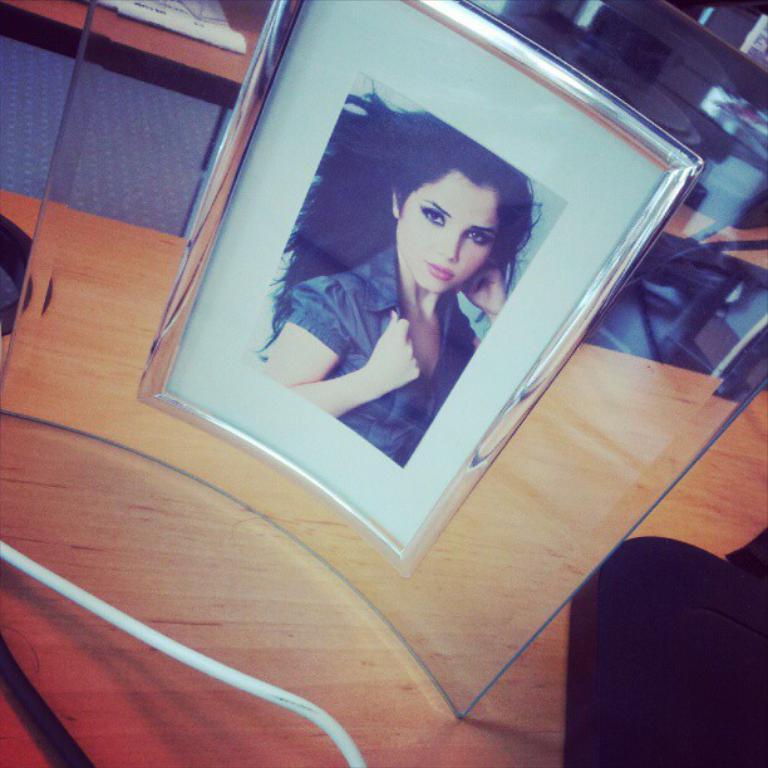Describe this image in one or two sentences. In this image we can see a photo frame of a woman on the wooden table, also we can see a black colored object on it, there are papers on the other table. 